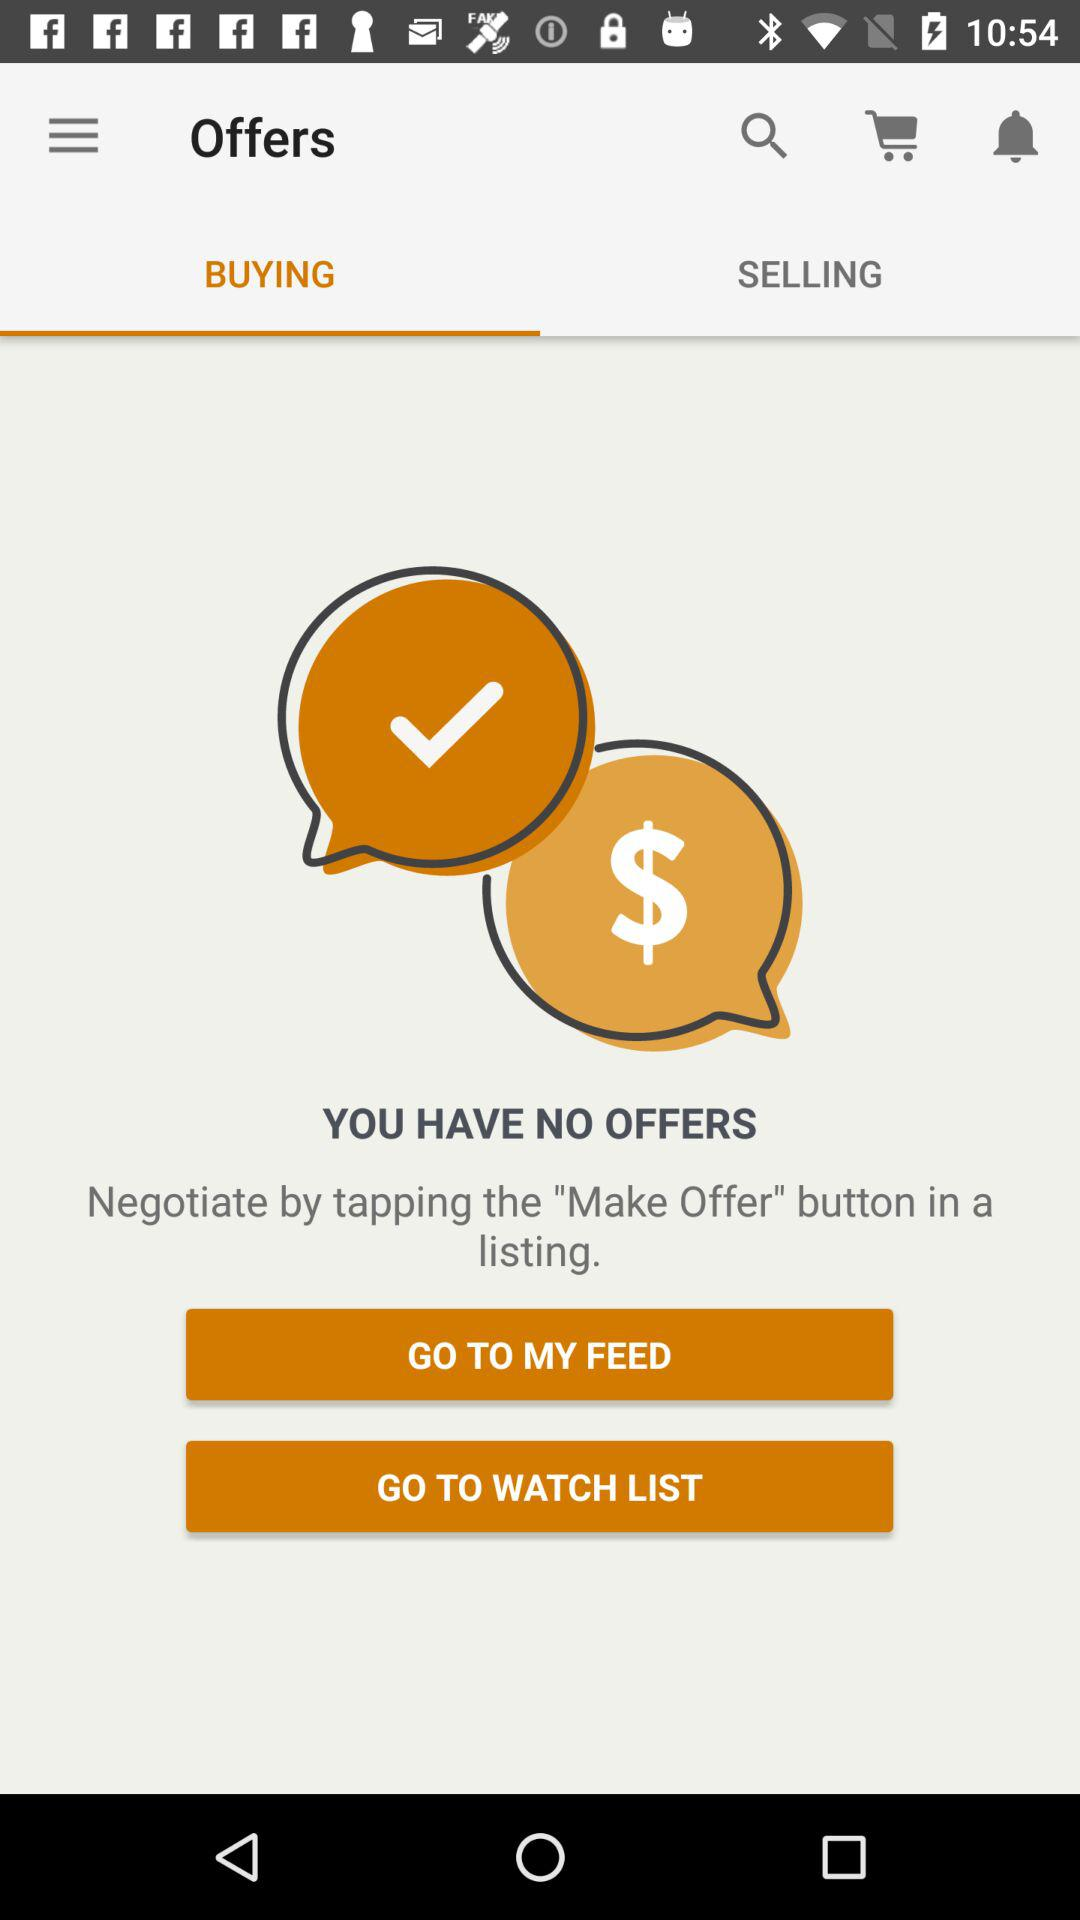Which tab is selected? The selected tab is "BUYING". 